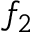Convert formula to latex. <formula><loc_0><loc_0><loc_500><loc_500>f _ { 2 }</formula> 